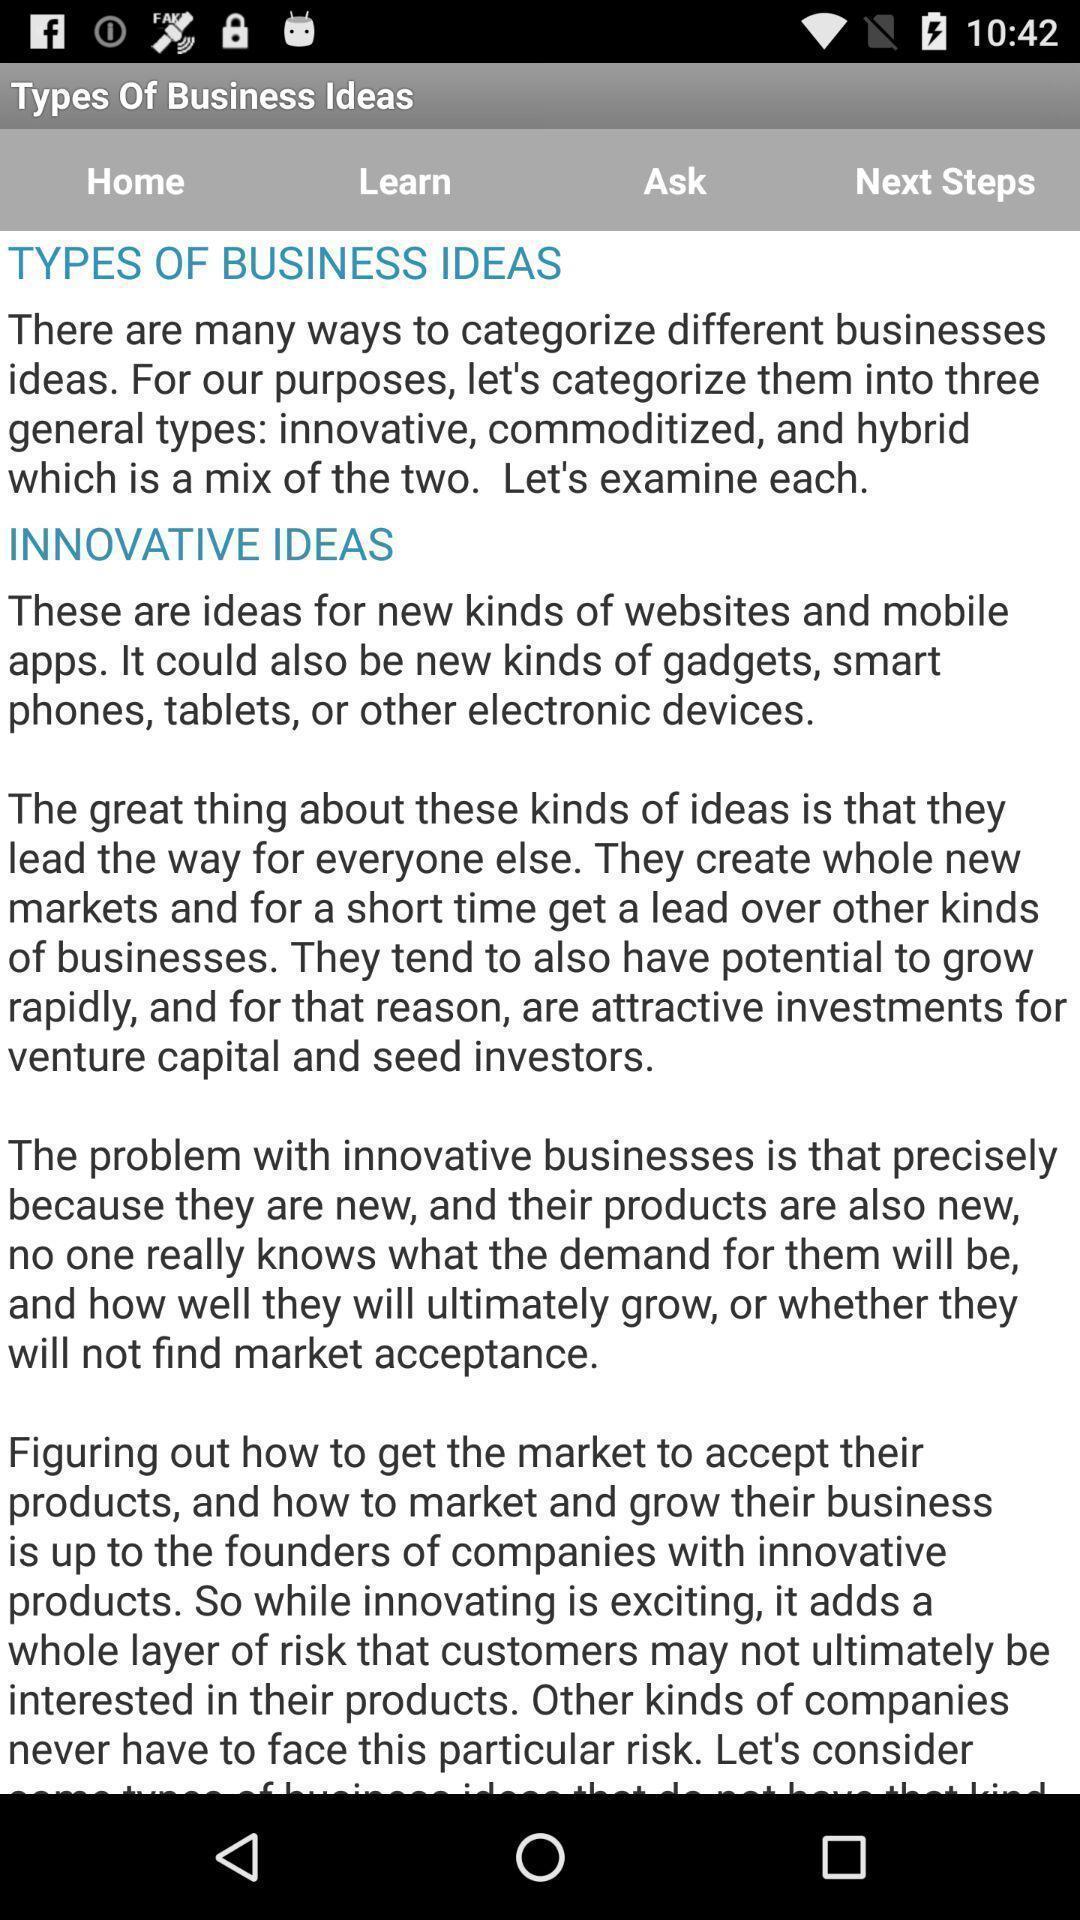Describe the key features of this screenshot. Page showing statement of a business app. 